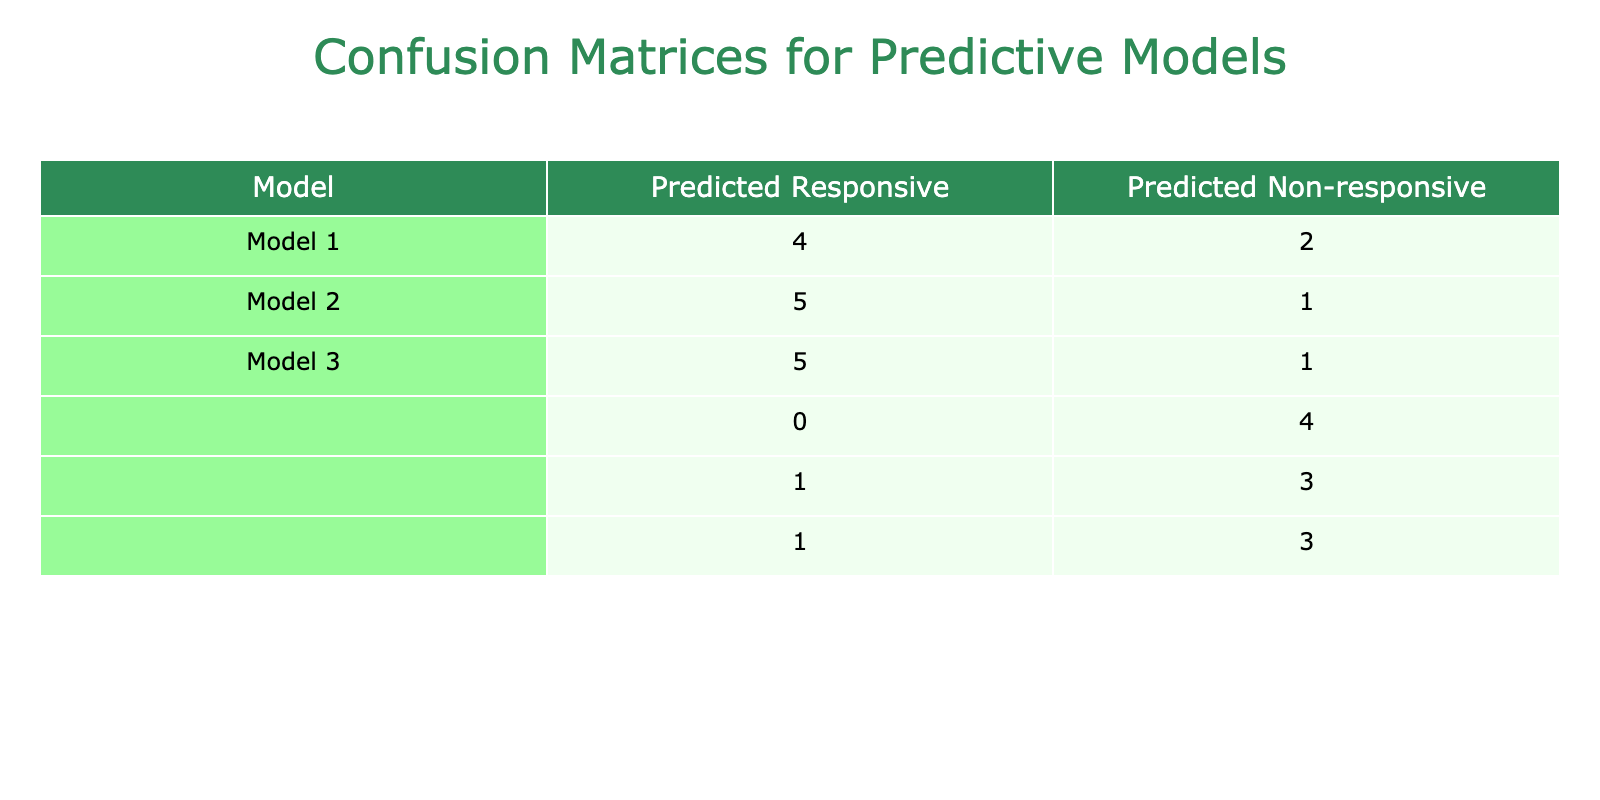What is the number of true positives for Predictive Model 1? From the table, we look for the cell that corresponds to 'Responsive' predicted by Predictive Model 1 and 'Responsive' actual response. Counting this value, we find that it is 4.
Answer: 4 What is the number of true negatives for Predictive Model 2? The true negatives are found in the cell representing 'Non-responsive' predicted by Predictive Model 2 and 'Non-responsive' actual response. From the table, this value is 5.
Answer: 5 What is the sum of false positives for all three models? The false positives are the counts where 'Responsive' is predicted but 'Non-responsive' is the actual response. For Model 1, the false positive is 0; for Model 2, it is 1; and for Model 3, it is 2. The sum is 0 + 1 + 2 = 3.
Answer: 3 Is Predictive Model 3 better than Predictive Model 1 in terms of predictive accuracy? To determine this, we calculate the accuracy for both models. Model 1 has 4 true positives and 5 true negatives out of 10 total cases, giving an accuracy of 90%. Model 3 has 4 true positives and 4 true negatives, resulting in an accuracy of 80%. Thus, Model 1 is more accurate.
Answer: No Which model had the highest number of incorrect predictions overall? The total incorrect predictions for each model consist of false positives and false negatives. For Model 1, there is 1 (false negative) + 0 (false positive) = 1; Model 2 has 1 + 0 = 1; Model 3 has 2 (false negatives) + 1 (false positive) = 3. Hence, Model 3 had the highest incorrect predictions.
Answer: Predictive Model 3 What is the average true positive rate across all models? The true positive rate is calculated as the average of the true positives for each model. For Model 1, it's 4; Model 2, it's 3; and Model 3, it's 4. The total is 4 + 3 + 4 = 11, divided by 3 gives us an average of approximately 3.67.
Answer: 3.67 Is there any model where the number of false negatives is zero? By checking the values in the table, the false negatives represent cases where an actual 'Responsive' was predicted as 'Non-responsive'. For all models, we find that Model 1 and Model 2 have false negative counts (1 and 1 respectively), while Model 3 has a count of 2. Hence, no model has zero false negatives.
Answer: No What is the false negative rate for Predictive Model 2? The false negative rate is calculated by taking the number of false negatives (which is 1 for Model 2) and dividing it by the total actual responses that are 'Responsive' (which is 4). Therefore, the false negative rate is 1/4 = 0.25.
Answer: 0.25 